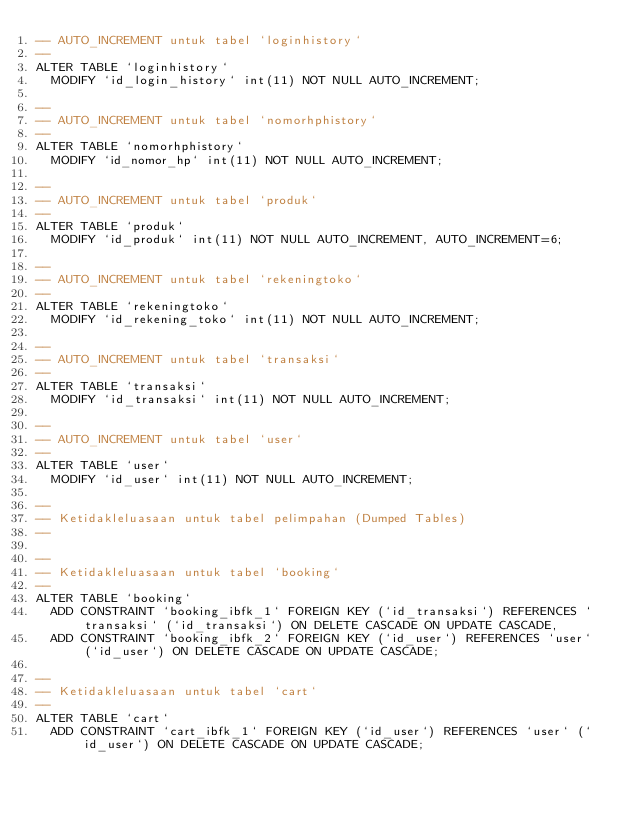Convert code to text. <code><loc_0><loc_0><loc_500><loc_500><_SQL_>-- AUTO_INCREMENT untuk tabel `loginhistory`
--
ALTER TABLE `loginhistory`
  MODIFY `id_login_history` int(11) NOT NULL AUTO_INCREMENT;

--
-- AUTO_INCREMENT untuk tabel `nomorhphistory`
--
ALTER TABLE `nomorhphistory`
  MODIFY `id_nomor_hp` int(11) NOT NULL AUTO_INCREMENT;

--
-- AUTO_INCREMENT untuk tabel `produk`
--
ALTER TABLE `produk`
  MODIFY `id_produk` int(11) NOT NULL AUTO_INCREMENT, AUTO_INCREMENT=6;

--
-- AUTO_INCREMENT untuk tabel `rekeningtoko`
--
ALTER TABLE `rekeningtoko`
  MODIFY `id_rekening_toko` int(11) NOT NULL AUTO_INCREMENT;

--
-- AUTO_INCREMENT untuk tabel `transaksi`
--
ALTER TABLE `transaksi`
  MODIFY `id_transaksi` int(11) NOT NULL AUTO_INCREMENT;

--
-- AUTO_INCREMENT untuk tabel `user`
--
ALTER TABLE `user`
  MODIFY `id_user` int(11) NOT NULL AUTO_INCREMENT;

--
-- Ketidakleluasaan untuk tabel pelimpahan (Dumped Tables)
--

--
-- Ketidakleluasaan untuk tabel `booking`
--
ALTER TABLE `booking`
  ADD CONSTRAINT `booking_ibfk_1` FOREIGN KEY (`id_transaksi`) REFERENCES `transaksi` (`id_transaksi`) ON DELETE CASCADE ON UPDATE CASCADE,
  ADD CONSTRAINT `booking_ibfk_2` FOREIGN KEY (`id_user`) REFERENCES `user` (`id_user`) ON DELETE CASCADE ON UPDATE CASCADE;

--
-- Ketidakleluasaan untuk tabel `cart`
--
ALTER TABLE `cart`
  ADD CONSTRAINT `cart_ibfk_1` FOREIGN KEY (`id_user`) REFERENCES `user` (`id_user`) ON DELETE CASCADE ON UPDATE CASCADE;
</code> 